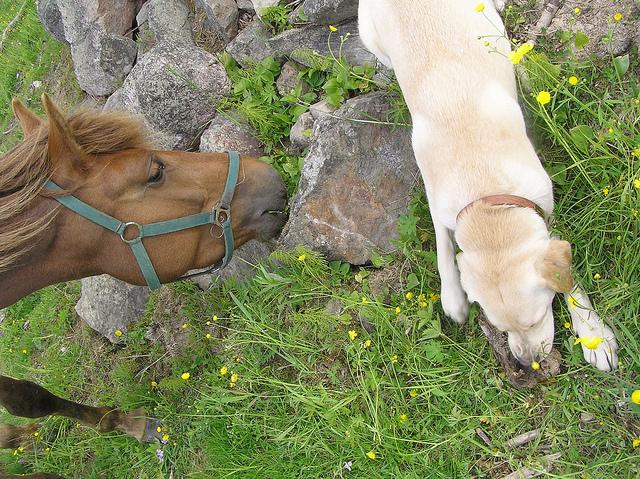What type of flowers are growing in the grass?
Concise answer only. Dandelions. What animals are pictured here?
Answer briefly. Horse and dog. What is the animal eating?
Answer briefly. Grass. What color is the horse?
Answer briefly. Brown. What color is the horse's mouth?
Quick response, please. Black. 